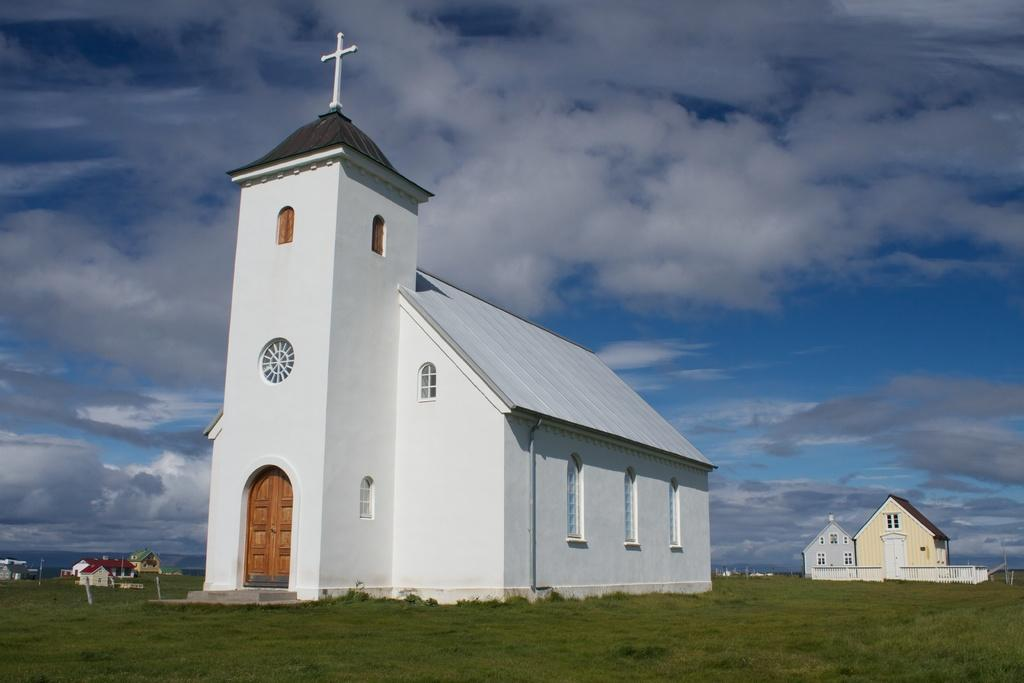What type of vegetation can be seen in the image? There is grass in the image. What type of building is depicted in the image? The image appears to depict a church. What other structures can be seen in the background of the image? There are houses in the background of the image. What is visible in the sky in the background of the image? Clouds are visible in the sky in the background of the image. What type of celery is being used as a neck support in the image? There is no celery or neck support present in the image. 